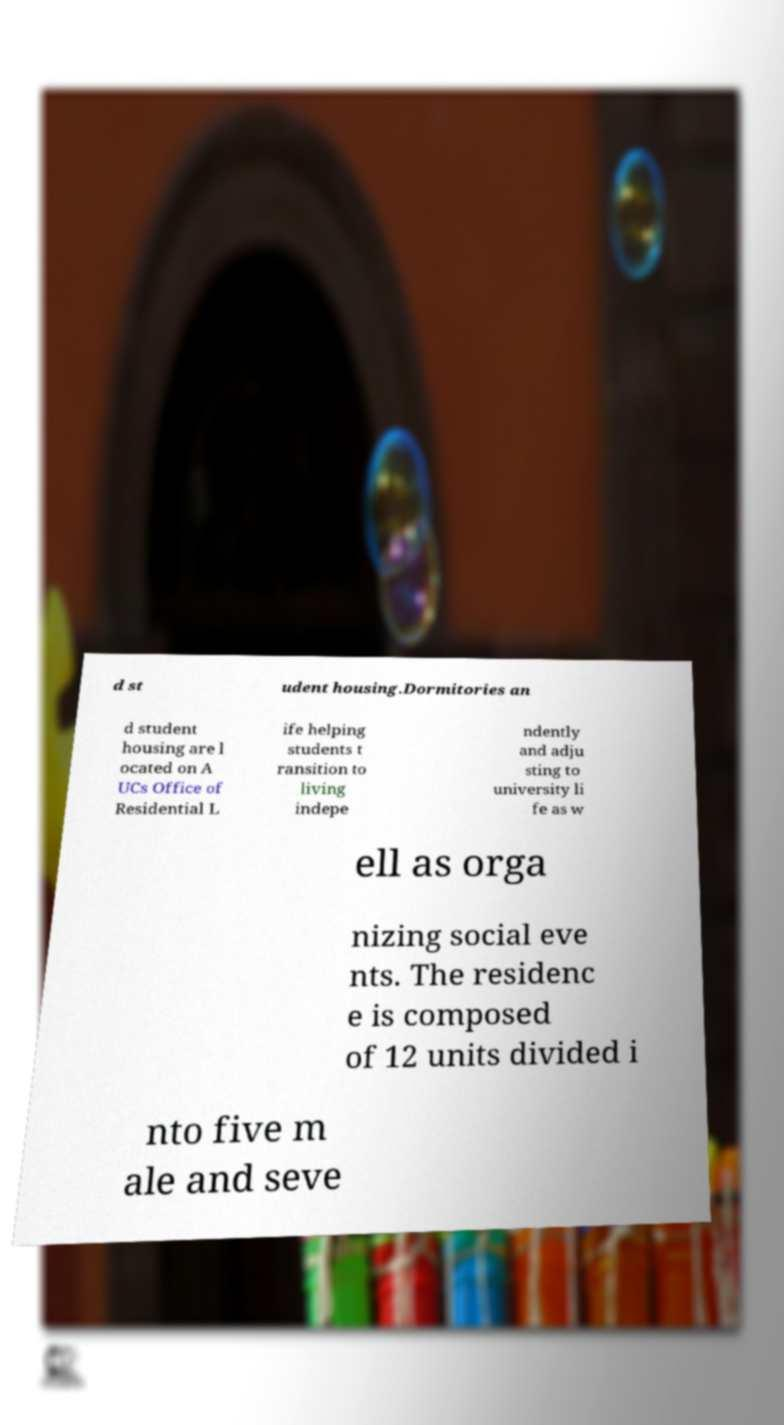Could you assist in decoding the text presented in this image and type it out clearly? d st udent housing.Dormitories an d student housing are l ocated on A UCs Office of Residential L ife helping students t ransition to living indepe ndently and adju sting to university li fe as w ell as orga nizing social eve nts. The residenc e is composed of 12 units divided i nto five m ale and seve 